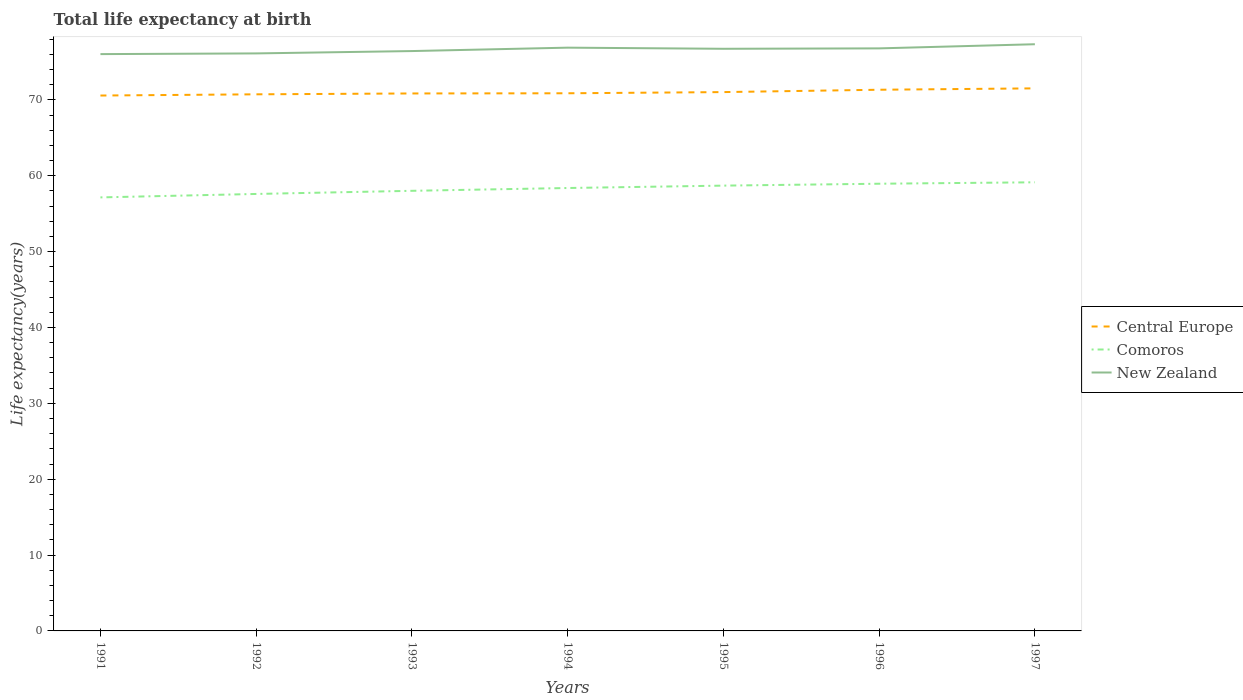Across all years, what is the maximum life expectancy at birth in in New Zealand?
Provide a short and direct response. 76.03. In which year was the life expectancy at birth in in Comoros maximum?
Ensure brevity in your answer.  1991. What is the total life expectancy at birth in in New Zealand in the graph?
Your answer should be very brief. -0.66. What is the difference between the highest and the second highest life expectancy at birth in in Comoros?
Keep it short and to the point. 1.99. How many lines are there?
Provide a short and direct response. 3. How many legend labels are there?
Offer a very short reply. 3. What is the title of the graph?
Your answer should be very brief. Total life expectancy at birth. Does "Equatorial Guinea" appear as one of the legend labels in the graph?
Your response must be concise. No. What is the label or title of the Y-axis?
Provide a succinct answer. Life expectancy(years). What is the Life expectancy(years) of Central Europe in 1991?
Your answer should be very brief. 70.57. What is the Life expectancy(years) in Comoros in 1991?
Provide a short and direct response. 57.15. What is the Life expectancy(years) of New Zealand in 1991?
Provide a succinct answer. 76.03. What is the Life expectancy(years) in Central Europe in 1992?
Make the answer very short. 70.73. What is the Life expectancy(years) of Comoros in 1992?
Your answer should be compact. 57.6. What is the Life expectancy(years) of New Zealand in 1992?
Ensure brevity in your answer.  76.12. What is the Life expectancy(years) of Central Europe in 1993?
Make the answer very short. 70.85. What is the Life expectancy(years) in Comoros in 1993?
Give a very brief answer. 58.01. What is the Life expectancy(years) in New Zealand in 1993?
Your answer should be very brief. 76.43. What is the Life expectancy(years) in Central Europe in 1994?
Offer a very short reply. 70.87. What is the Life expectancy(years) of Comoros in 1994?
Your response must be concise. 58.38. What is the Life expectancy(years) in New Zealand in 1994?
Keep it short and to the point. 76.88. What is the Life expectancy(years) in Central Europe in 1995?
Offer a terse response. 71.03. What is the Life expectancy(years) in Comoros in 1995?
Keep it short and to the point. 58.7. What is the Life expectancy(years) in New Zealand in 1995?
Offer a very short reply. 76.73. What is the Life expectancy(years) of Central Europe in 1996?
Offer a terse response. 71.34. What is the Life expectancy(years) in Comoros in 1996?
Give a very brief answer. 58.95. What is the Life expectancy(years) of New Zealand in 1996?
Your answer should be very brief. 76.79. What is the Life expectancy(years) of Central Europe in 1997?
Give a very brief answer. 71.52. What is the Life expectancy(years) of Comoros in 1997?
Give a very brief answer. 59.14. What is the Life expectancy(years) in New Zealand in 1997?
Ensure brevity in your answer.  77.33. Across all years, what is the maximum Life expectancy(years) of Central Europe?
Your answer should be compact. 71.52. Across all years, what is the maximum Life expectancy(years) of Comoros?
Provide a short and direct response. 59.14. Across all years, what is the maximum Life expectancy(years) in New Zealand?
Provide a short and direct response. 77.33. Across all years, what is the minimum Life expectancy(years) of Central Europe?
Provide a short and direct response. 70.57. Across all years, what is the minimum Life expectancy(years) in Comoros?
Your response must be concise. 57.15. Across all years, what is the minimum Life expectancy(years) of New Zealand?
Provide a short and direct response. 76.03. What is the total Life expectancy(years) in Central Europe in the graph?
Your answer should be very brief. 496.9. What is the total Life expectancy(years) in Comoros in the graph?
Offer a terse response. 407.92. What is the total Life expectancy(years) of New Zealand in the graph?
Provide a short and direct response. 536.33. What is the difference between the Life expectancy(years) in Central Europe in 1991 and that in 1992?
Give a very brief answer. -0.16. What is the difference between the Life expectancy(years) in Comoros in 1991 and that in 1992?
Keep it short and to the point. -0.45. What is the difference between the Life expectancy(years) of New Zealand in 1991 and that in 1992?
Provide a succinct answer. -0.09. What is the difference between the Life expectancy(years) in Central Europe in 1991 and that in 1993?
Your response must be concise. -0.27. What is the difference between the Life expectancy(years) of Comoros in 1991 and that in 1993?
Provide a succinct answer. -0.87. What is the difference between the Life expectancy(years) in New Zealand in 1991 and that in 1993?
Keep it short and to the point. -0.4. What is the difference between the Life expectancy(years) of Central Europe in 1991 and that in 1994?
Provide a succinct answer. -0.3. What is the difference between the Life expectancy(years) in Comoros in 1991 and that in 1994?
Your response must be concise. -1.24. What is the difference between the Life expectancy(years) in New Zealand in 1991 and that in 1994?
Ensure brevity in your answer.  -0.85. What is the difference between the Life expectancy(years) in Central Europe in 1991 and that in 1995?
Your response must be concise. -0.45. What is the difference between the Life expectancy(years) of Comoros in 1991 and that in 1995?
Offer a very short reply. -1.55. What is the difference between the Life expectancy(years) of New Zealand in 1991 and that in 1995?
Provide a short and direct response. -0.7. What is the difference between the Life expectancy(years) in Central Europe in 1991 and that in 1996?
Ensure brevity in your answer.  -0.76. What is the difference between the Life expectancy(years) of Comoros in 1991 and that in 1996?
Offer a very short reply. -1.8. What is the difference between the Life expectancy(years) in New Zealand in 1991 and that in 1996?
Your answer should be very brief. -0.76. What is the difference between the Life expectancy(years) in Central Europe in 1991 and that in 1997?
Provide a short and direct response. -0.94. What is the difference between the Life expectancy(years) in Comoros in 1991 and that in 1997?
Offer a terse response. -1.99. What is the difference between the Life expectancy(years) in New Zealand in 1991 and that in 1997?
Keep it short and to the point. -1.3. What is the difference between the Life expectancy(years) of Central Europe in 1992 and that in 1993?
Ensure brevity in your answer.  -0.11. What is the difference between the Life expectancy(years) in Comoros in 1992 and that in 1993?
Ensure brevity in your answer.  -0.41. What is the difference between the Life expectancy(years) in New Zealand in 1992 and that in 1993?
Your response must be concise. -0.31. What is the difference between the Life expectancy(years) of Central Europe in 1992 and that in 1994?
Offer a terse response. -0.14. What is the difference between the Life expectancy(years) in Comoros in 1992 and that in 1994?
Your answer should be compact. -0.78. What is the difference between the Life expectancy(years) in New Zealand in 1992 and that in 1994?
Offer a very short reply. -0.76. What is the difference between the Life expectancy(years) of Central Europe in 1992 and that in 1995?
Your response must be concise. -0.29. What is the difference between the Life expectancy(years) of Comoros in 1992 and that in 1995?
Your answer should be very brief. -1.1. What is the difference between the Life expectancy(years) in New Zealand in 1992 and that in 1995?
Your answer should be very brief. -0.61. What is the difference between the Life expectancy(years) of Central Europe in 1992 and that in 1996?
Provide a succinct answer. -0.6. What is the difference between the Life expectancy(years) of Comoros in 1992 and that in 1996?
Your response must be concise. -1.35. What is the difference between the Life expectancy(years) of New Zealand in 1992 and that in 1996?
Your answer should be very brief. -0.66. What is the difference between the Life expectancy(years) of Central Europe in 1992 and that in 1997?
Your answer should be very brief. -0.79. What is the difference between the Life expectancy(years) of Comoros in 1992 and that in 1997?
Your response must be concise. -1.54. What is the difference between the Life expectancy(years) of New Zealand in 1992 and that in 1997?
Offer a very short reply. -1.21. What is the difference between the Life expectancy(years) in Central Europe in 1993 and that in 1994?
Keep it short and to the point. -0.02. What is the difference between the Life expectancy(years) in Comoros in 1993 and that in 1994?
Ensure brevity in your answer.  -0.37. What is the difference between the Life expectancy(years) in New Zealand in 1993 and that in 1994?
Provide a succinct answer. -0.45. What is the difference between the Life expectancy(years) in Central Europe in 1993 and that in 1995?
Ensure brevity in your answer.  -0.18. What is the difference between the Life expectancy(years) in Comoros in 1993 and that in 1995?
Your answer should be compact. -0.68. What is the difference between the Life expectancy(years) in New Zealand in 1993 and that in 1995?
Keep it short and to the point. -0.3. What is the difference between the Life expectancy(years) of Central Europe in 1993 and that in 1996?
Provide a succinct answer. -0.49. What is the difference between the Life expectancy(years) of Comoros in 1993 and that in 1996?
Make the answer very short. -0.93. What is the difference between the Life expectancy(years) in New Zealand in 1993 and that in 1996?
Provide a succinct answer. -0.35. What is the difference between the Life expectancy(years) in Central Europe in 1993 and that in 1997?
Your answer should be compact. -0.67. What is the difference between the Life expectancy(years) in Comoros in 1993 and that in 1997?
Offer a very short reply. -1.12. What is the difference between the Life expectancy(years) of Central Europe in 1994 and that in 1995?
Give a very brief answer. -0.16. What is the difference between the Life expectancy(years) of Comoros in 1994 and that in 1995?
Give a very brief answer. -0.31. What is the difference between the Life expectancy(years) in New Zealand in 1994 and that in 1995?
Ensure brevity in your answer.  0.15. What is the difference between the Life expectancy(years) of Central Europe in 1994 and that in 1996?
Your answer should be compact. -0.47. What is the difference between the Life expectancy(years) of Comoros in 1994 and that in 1996?
Your response must be concise. -0.56. What is the difference between the Life expectancy(years) of New Zealand in 1994 and that in 1996?
Ensure brevity in your answer.  0.1. What is the difference between the Life expectancy(years) in Central Europe in 1994 and that in 1997?
Offer a very short reply. -0.65. What is the difference between the Life expectancy(years) in Comoros in 1994 and that in 1997?
Your answer should be compact. -0.75. What is the difference between the Life expectancy(years) of New Zealand in 1994 and that in 1997?
Provide a short and direct response. -0.45. What is the difference between the Life expectancy(years) in Central Europe in 1995 and that in 1996?
Make the answer very short. -0.31. What is the difference between the Life expectancy(years) in Comoros in 1995 and that in 1996?
Your answer should be very brief. -0.25. What is the difference between the Life expectancy(years) in New Zealand in 1995 and that in 1996?
Provide a succinct answer. -0.05. What is the difference between the Life expectancy(years) of Central Europe in 1995 and that in 1997?
Keep it short and to the point. -0.49. What is the difference between the Life expectancy(years) in Comoros in 1995 and that in 1997?
Offer a very short reply. -0.44. What is the difference between the Life expectancy(years) of Central Europe in 1996 and that in 1997?
Provide a succinct answer. -0.18. What is the difference between the Life expectancy(years) in Comoros in 1996 and that in 1997?
Provide a short and direct response. -0.19. What is the difference between the Life expectancy(years) in New Zealand in 1996 and that in 1997?
Keep it short and to the point. -0.55. What is the difference between the Life expectancy(years) of Central Europe in 1991 and the Life expectancy(years) of Comoros in 1992?
Provide a succinct answer. 12.97. What is the difference between the Life expectancy(years) of Central Europe in 1991 and the Life expectancy(years) of New Zealand in 1992?
Your answer should be compact. -5.55. What is the difference between the Life expectancy(years) of Comoros in 1991 and the Life expectancy(years) of New Zealand in 1992?
Offer a terse response. -18.98. What is the difference between the Life expectancy(years) of Central Europe in 1991 and the Life expectancy(years) of Comoros in 1993?
Your answer should be compact. 12.56. What is the difference between the Life expectancy(years) of Central Europe in 1991 and the Life expectancy(years) of New Zealand in 1993?
Keep it short and to the point. -5.86. What is the difference between the Life expectancy(years) in Comoros in 1991 and the Life expectancy(years) in New Zealand in 1993?
Give a very brief answer. -19.29. What is the difference between the Life expectancy(years) of Central Europe in 1991 and the Life expectancy(years) of Comoros in 1994?
Make the answer very short. 12.19. What is the difference between the Life expectancy(years) of Central Europe in 1991 and the Life expectancy(years) of New Zealand in 1994?
Your response must be concise. -6.31. What is the difference between the Life expectancy(years) in Comoros in 1991 and the Life expectancy(years) in New Zealand in 1994?
Your answer should be compact. -19.74. What is the difference between the Life expectancy(years) in Central Europe in 1991 and the Life expectancy(years) in Comoros in 1995?
Provide a short and direct response. 11.88. What is the difference between the Life expectancy(years) of Central Europe in 1991 and the Life expectancy(years) of New Zealand in 1995?
Keep it short and to the point. -6.16. What is the difference between the Life expectancy(years) of Comoros in 1991 and the Life expectancy(years) of New Zealand in 1995?
Offer a very short reply. -19.59. What is the difference between the Life expectancy(years) in Central Europe in 1991 and the Life expectancy(years) in Comoros in 1996?
Give a very brief answer. 11.63. What is the difference between the Life expectancy(years) of Central Europe in 1991 and the Life expectancy(years) of New Zealand in 1996?
Your response must be concise. -6.22. What is the difference between the Life expectancy(years) in Comoros in 1991 and the Life expectancy(years) in New Zealand in 1996?
Your response must be concise. -19.64. What is the difference between the Life expectancy(years) in Central Europe in 1991 and the Life expectancy(years) in Comoros in 1997?
Provide a short and direct response. 11.44. What is the difference between the Life expectancy(years) of Central Europe in 1991 and the Life expectancy(years) of New Zealand in 1997?
Give a very brief answer. -6.76. What is the difference between the Life expectancy(years) in Comoros in 1991 and the Life expectancy(years) in New Zealand in 1997?
Offer a terse response. -20.19. What is the difference between the Life expectancy(years) in Central Europe in 1992 and the Life expectancy(years) in Comoros in 1993?
Make the answer very short. 12.72. What is the difference between the Life expectancy(years) in Central Europe in 1992 and the Life expectancy(years) in New Zealand in 1993?
Your answer should be compact. -5.7. What is the difference between the Life expectancy(years) in Comoros in 1992 and the Life expectancy(years) in New Zealand in 1993?
Provide a short and direct response. -18.83. What is the difference between the Life expectancy(years) of Central Europe in 1992 and the Life expectancy(years) of Comoros in 1994?
Your answer should be compact. 12.35. What is the difference between the Life expectancy(years) in Central Europe in 1992 and the Life expectancy(years) in New Zealand in 1994?
Keep it short and to the point. -6.15. What is the difference between the Life expectancy(years) of Comoros in 1992 and the Life expectancy(years) of New Zealand in 1994?
Your response must be concise. -19.28. What is the difference between the Life expectancy(years) in Central Europe in 1992 and the Life expectancy(years) in Comoros in 1995?
Offer a very short reply. 12.04. What is the difference between the Life expectancy(years) in Central Europe in 1992 and the Life expectancy(years) in New Zealand in 1995?
Keep it short and to the point. -6. What is the difference between the Life expectancy(years) in Comoros in 1992 and the Life expectancy(years) in New Zealand in 1995?
Your answer should be compact. -19.13. What is the difference between the Life expectancy(years) of Central Europe in 1992 and the Life expectancy(years) of Comoros in 1996?
Your answer should be compact. 11.79. What is the difference between the Life expectancy(years) of Central Europe in 1992 and the Life expectancy(years) of New Zealand in 1996?
Make the answer very short. -6.06. What is the difference between the Life expectancy(years) in Comoros in 1992 and the Life expectancy(years) in New Zealand in 1996?
Your answer should be compact. -19.19. What is the difference between the Life expectancy(years) in Central Europe in 1992 and the Life expectancy(years) in Comoros in 1997?
Offer a very short reply. 11.6. What is the difference between the Life expectancy(years) in Central Europe in 1992 and the Life expectancy(years) in New Zealand in 1997?
Offer a very short reply. -6.6. What is the difference between the Life expectancy(years) of Comoros in 1992 and the Life expectancy(years) of New Zealand in 1997?
Ensure brevity in your answer.  -19.73. What is the difference between the Life expectancy(years) in Central Europe in 1993 and the Life expectancy(years) in Comoros in 1994?
Provide a succinct answer. 12.46. What is the difference between the Life expectancy(years) in Central Europe in 1993 and the Life expectancy(years) in New Zealand in 1994?
Make the answer very short. -6.04. What is the difference between the Life expectancy(years) of Comoros in 1993 and the Life expectancy(years) of New Zealand in 1994?
Keep it short and to the point. -18.87. What is the difference between the Life expectancy(years) of Central Europe in 1993 and the Life expectancy(years) of Comoros in 1995?
Provide a succinct answer. 12.15. What is the difference between the Life expectancy(years) of Central Europe in 1993 and the Life expectancy(years) of New Zealand in 1995?
Ensure brevity in your answer.  -5.89. What is the difference between the Life expectancy(years) in Comoros in 1993 and the Life expectancy(years) in New Zealand in 1995?
Your answer should be compact. -18.72. What is the difference between the Life expectancy(years) in Central Europe in 1993 and the Life expectancy(years) in Comoros in 1996?
Ensure brevity in your answer.  11.9. What is the difference between the Life expectancy(years) in Central Europe in 1993 and the Life expectancy(years) in New Zealand in 1996?
Offer a terse response. -5.94. What is the difference between the Life expectancy(years) in Comoros in 1993 and the Life expectancy(years) in New Zealand in 1996?
Offer a terse response. -18.77. What is the difference between the Life expectancy(years) of Central Europe in 1993 and the Life expectancy(years) of Comoros in 1997?
Your answer should be very brief. 11.71. What is the difference between the Life expectancy(years) of Central Europe in 1993 and the Life expectancy(years) of New Zealand in 1997?
Offer a terse response. -6.49. What is the difference between the Life expectancy(years) in Comoros in 1993 and the Life expectancy(years) in New Zealand in 1997?
Offer a very short reply. -19.32. What is the difference between the Life expectancy(years) of Central Europe in 1994 and the Life expectancy(years) of Comoros in 1995?
Give a very brief answer. 12.17. What is the difference between the Life expectancy(years) in Central Europe in 1994 and the Life expectancy(years) in New Zealand in 1995?
Give a very brief answer. -5.86. What is the difference between the Life expectancy(years) of Comoros in 1994 and the Life expectancy(years) of New Zealand in 1995?
Your response must be concise. -18.35. What is the difference between the Life expectancy(years) in Central Europe in 1994 and the Life expectancy(years) in Comoros in 1996?
Provide a succinct answer. 11.92. What is the difference between the Life expectancy(years) of Central Europe in 1994 and the Life expectancy(years) of New Zealand in 1996?
Provide a succinct answer. -5.92. What is the difference between the Life expectancy(years) in Comoros in 1994 and the Life expectancy(years) in New Zealand in 1996?
Your answer should be compact. -18.41. What is the difference between the Life expectancy(years) of Central Europe in 1994 and the Life expectancy(years) of Comoros in 1997?
Provide a short and direct response. 11.73. What is the difference between the Life expectancy(years) in Central Europe in 1994 and the Life expectancy(years) in New Zealand in 1997?
Offer a terse response. -6.46. What is the difference between the Life expectancy(years) in Comoros in 1994 and the Life expectancy(years) in New Zealand in 1997?
Give a very brief answer. -18.95. What is the difference between the Life expectancy(years) in Central Europe in 1995 and the Life expectancy(years) in Comoros in 1996?
Your response must be concise. 12.08. What is the difference between the Life expectancy(years) in Central Europe in 1995 and the Life expectancy(years) in New Zealand in 1996?
Offer a very short reply. -5.76. What is the difference between the Life expectancy(years) in Comoros in 1995 and the Life expectancy(years) in New Zealand in 1996?
Offer a very short reply. -18.09. What is the difference between the Life expectancy(years) in Central Europe in 1995 and the Life expectancy(years) in Comoros in 1997?
Keep it short and to the point. 11.89. What is the difference between the Life expectancy(years) of Central Europe in 1995 and the Life expectancy(years) of New Zealand in 1997?
Offer a terse response. -6.31. What is the difference between the Life expectancy(years) of Comoros in 1995 and the Life expectancy(years) of New Zealand in 1997?
Provide a short and direct response. -18.64. What is the difference between the Life expectancy(years) of Central Europe in 1996 and the Life expectancy(years) of Comoros in 1997?
Ensure brevity in your answer.  12.2. What is the difference between the Life expectancy(years) in Central Europe in 1996 and the Life expectancy(years) in New Zealand in 1997?
Provide a short and direct response. -6. What is the difference between the Life expectancy(years) in Comoros in 1996 and the Life expectancy(years) in New Zealand in 1997?
Make the answer very short. -18.39. What is the average Life expectancy(years) in Central Europe per year?
Your answer should be very brief. 70.99. What is the average Life expectancy(years) of Comoros per year?
Provide a succinct answer. 58.27. What is the average Life expectancy(years) in New Zealand per year?
Ensure brevity in your answer.  76.62. In the year 1991, what is the difference between the Life expectancy(years) in Central Europe and Life expectancy(years) in Comoros?
Make the answer very short. 13.43. In the year 1991, what is the difference between the Life expectancy(years) in Central Europe and Life expectancy(years) in New Zealand?
Offer a terse response. -5.46. In the year 1991, what is the difference between the Life expectancy(years) of Comoros and Life expectancy(years) of New Zealand?
Offer a very short reply. -18.89. In the year 1992, what is the difference between the Life expectancy(years) of Central Europe and Life expectancy(years) of Comoros?
Your answer should be compact. 13.13. In the year 1992, what is the difference between the Life expectancy(years) of Central Europe and Life expectancy(years) of New Zealand?
Offer a terse response. -5.39. In the year 1992, what is the difference between the Life expectancy(years) in Comoros and Life expectancy(years) in New Zealand?
Your answer should be very brief. -18.52. In the year 1993, what is the difference between the Life expectancy(years) in Central Europe and Life expectancy(years) in Comoros?
Make the answer very short. 12.83. In the year 1993, what is the difference between the Life expectancy(years) in Central Europe and Life expectancy(years) in New Zealand?
Give a very brief answer. -5.59. In the year 1993, what is the difference between the Life expectancy(years) in Comoros and Life expectancy(years) in New Zealand?
Your answer should be very brief. -18.42. In the year 1994, what is the difference between the Life expectancy(years) in Central Europe and Life expectancy(years) in Comoros?
Give a very brief answer. 12.49. In the year 1994, what is the difference between the Life expectancy(years) of Central Europe and Life expectancy(years) of New Zealand?
Your answer should be compact. -6.01. In the year 1994, what is the difference between the Life expectancy(years) of Comoros and Life expectancy(years) of New Zealand?
Offer a very short reply. -18.5. In the year 1995, what is the difference between the Life expectancy(years) in Central Europe and Life expectancy(years) in Comoros?
Offer a very short reply. 12.33. In the year 1995, what is the difference between the Life expectancy(years) of Central Europe and Life expectancy(years) of New Zealand?
Offer a terse response. -5.71. In the year 1995, what is the difference between the Life expectancy(years) in Comoros and Life expectancy(years) in New Zealand?
Provide a short and direct response. -18.04. In the year 1996, what is the difference between the Life expectancy(years) of Central Europe and Life expectancy(years) of Comoros?
Provide a short and direct response. 12.39. In the year 1996, what is the difference between the Life expectancy(years) in Central Europe and Life expectancy(years) in New Zealand?
Provide a succinct answer. -5.45. In the year 1996, what is the difference between the Life expectancy(years) in Comoros and Life expectancy(years) in New Zealand?
Provide a short and direct response. -17.84. In the year 1997, what is the difference between the Life expectancy(years) in Central Europe and Life expectancy(years) in Comoros?
Your response must be concise. 12.38. In the year 1997, what is the difference between the Life expectancy(years) of Central Europe and Life expectancy(years) of New Zealand?
Offer a very short reply. -5.82. In the year 1997, what is the difference between the Life expectancy(years) in Comoros and Life expectancy(years) in New Zealand?
Offer a terse response. -18.2. What is the ratio of the Life expectancy(years) of Central Europe in 1991 to that in 1992?
Your answer should be very brief. 1. What is the ratio of the Life expectancy(years) in New Zealand in 1991 to that in 1992?
Your response must be concise. 1. What is the ratio of the Life expectancy(years) of Comoros in 1991 to that in 1993?
Your answer should be compact. 0.98. What is the ratio of the Life expectancy(years) in New Zealand in 1991 to that in 1993?
Offer a very short reply. 0.99. What is the ratio of the Life expectancy(years) in Central Europe in 1991 to that in 1994?
Ensure brevity in your answer.  1. What is the ratio of the Life expectancy(years) of Comoros in 1991 to that in 1994?
Ensure brevity in your answer.  0.98. What is the ratio of the Life expectancy(years) in New Zealand in 1991 to that in 1994?
Give a very brief answer. 0.99. What is the ratio of the Life expectancy(years) in Comoros in 1991 to that in 1995?
Provide a succinct answer. 0.97. What is the ratio of the Life expectancy(years) of Central Europe in 1991 to that in 1996?
Keep it short and to the point. 0.99. What is the ratio of the Life expectancy(years) in Comoros in 1991 to that in 1996?
Offer a terse response. 0.97. What is the ratio of the Life expectancy(years) of New Zealand in 1991 to that in 1996?
Give a very brief answer. 0.99. What is the ratio of the Life expectancy(years) of Central Europe in 1991 to that in 1997?
Make the answer very short. 0.99. What is the ratio of the Life expectancy(years) in Comoros in 1991 to that in 1997?
Give a very brief answer. 0.97. What is the ratio of the Life expectancy(years) of New Zealand in 1991 to that in 1997?
Keep it short and to the point. 0.98. What is the ratio of the Life expectancy(years) of Comoros in 1992 to that in 1993?
Your answer should be compact. 0.99. What is the ratio of the Life expectancy(years) of New Zealand in 1992 to that in 1993?
Provide a short and direct response. 1. What is the ratio of the Life expectancy(years) in Comoros in 1992 to that in 1994?
Offer a very short reply. 0.99. What is the ratio of the Life expectancy(years) in Comoros in 1992 to that in 1995?
Ensure brevity in your answer.  0.98. What is the ratio of the Life expectancy(years) in New Zealand in 1992 to that in 1995?
Give a very brief answer. 0.99. What is the ratio of the Life expectancy(years) in Comoros in 1992 to that in 1996?
Your answer should be compact. 0.98. What is the ratio of the Life expectancy(years) in New Zealand in 1992 to that in 1996?
Your response must be concise. 0.99. What is the ratio of the Life expectancy(years) in Central Europe in 1992 to that in 1997?
Your response must be concise. 0.99. What is the ratio of the Life expectancy(years) of New Zealand in 1992 to that in 1997?
Offer a terse response. 0.98. What is the ratio of the Life expectancy(years) of New Zealand in 1993 to that in 1994?
Provide a succinct answer. 0.99. What is the ratio of the Life expectancy(years) of Central Europe in 1993 to that in 1995?
Make the answer very short. 1. What is the ratio of the Life expectancy(years) in Comoros in 1993 to that in 1995?
Provide a short and direct response. 0.99. What is the ratio of the Life expectancy(years) of New Zealand in 1993 to that in 1995?
Offer a terse response. 1. What is the ratio of the Life expectancy(years) of Comoros in 1993 to that in 1996?
Give a very brief answer. 0.98. What is the ratio of the Life expectancy(years) of New Zealand in 1993 to that in 1996?
Make the answer very short. 1. What is the ratio of the Life expectancy(years) of Central Europe in 1993 to that in 1997?
Your response must be concise. 0.99. What is the ratio of the Life expectancy(years) of New Zealand in 1993 to that in 1997?
Keep it short and to the point. 0.99. What is the ratio of the Life expectancy(years) of Central Europe in 1994 to that in 1995?
Provide a short and direct response. 1. What is the ratio of the Life expectancy(years) of New Zealand in 1994 to that in 1995?
Your answer should be very brief. 1. What is the ratio of the Life expectancy(years) of Central Europe in 1994 to that in 1996?
Make the answer very short. 0.99. What is the ratio of the Life expectancy(years) of Central Europe in 1994 to that in 1997?
Offer a very short reply. 0.99. What is the ratio of the Life expectancy(years) in Comoros in 1994 to that in 1997?
Your answer should be compact. 0.99. What is the ratio of the Life expectancy(years) in New Zealand in 1994 to that in 1997?
Provide a succinct answer. 0.99. What is the ratio of the Life expectancy(years) of Comoros in 1995 to that in 1996?
Keep it short and to the point. 1. What is the ratio of the Life expectancy(years) of New Zealand in 1995 to that in 1996?
Your answer should be very brief. 1. What is the ratio of the Life expectancy(years) in Comoros in 1995 to that in 1997?
Ensure brevity in your answer.  0.99. What is the ratio of the Life expectancy(years) of New Zealand in 1995 to that in 1997?
Offer a terse response. 0.99. What is the ratio of the Life expectancy(years) of New Zealand in 1996 to that in 1997?
Offer a terse response. 0.99. What is the difference between the highest and the second highest Life expectancy(years) in Central Europe?
Your response must be concise. 0.18. What is the difference between the highest and the second highest Life expectancy(years) of Comoros?
Your answer should be compact. 0.19. What is the difference between the highest and the second highest Life expectancy(years) in New Zealand?
Keep it short and to the point. 0.45. What is the difference between the highest and the lowest Life expectancy(years) of Central Europe?
Your answer should be compact. 0.94. What is the difference between the highest and the lowest Life expectancy(years) of Comoros?
Provide a short and direct response. 1.99. What is the difference between the highest and the lowest Life expectancy(years) in New Zealand?
Offer a very short reply. 1.3. 